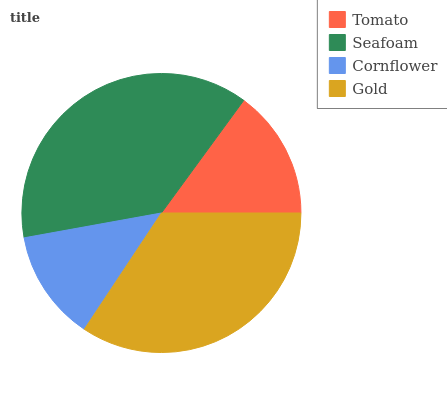Is Cornflower the minimum?
Answer yes or no. Yes. Is Seafoam the maximum?
Answer yes or no. Yes. Is Seafoam the minimum?
Answer yes or no. No. Is Cornflower the maximum?
Answer yes or no. No. Is Seafoam greater than Cornflower?
Answer yes or no. Yes. Is Cornflower less than Seafoam?
Answer yes or no. Yes. Is Cornflower greater than Seafoam?
Answer yes or no. No. Is Seafoam less than Cornflower?
Answer yes or no. No. Is Gold the high median?
Answer yes or no. Yes. Is Tomato the low median?
Answer yes or no. Yes. Is Tomato the high median?
Answer yes or no. No. Is Gold the low median?
Answer yes or no. No. 